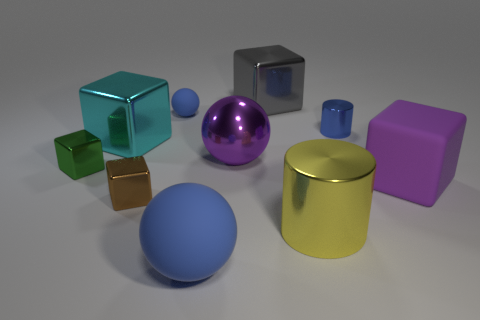Subtract all big purple spheres. How many spheres are left? 2 Subtract all balls. How many objects are left? 7 Subtract 1 blocks. How many blocks are left? 4 Subtract all blue spheres. How many spheres are left? 1 Add 9 blue shiny cylinders. How many blue shiny cylinders are left? 10 Add 8 cyan metallic objects. How many cyan metallic objects exist? 9 Subtract 0 gray balls. How many objects are left? 10 Subtract all red blocks. Subtract all blue cylinders. How many blocks are left? 5 Subtract all gray balls. How many green blocks are left? 1 Subtract all blocks. Subtract all tiny blue rubber spheres. How many objects are left? 4 